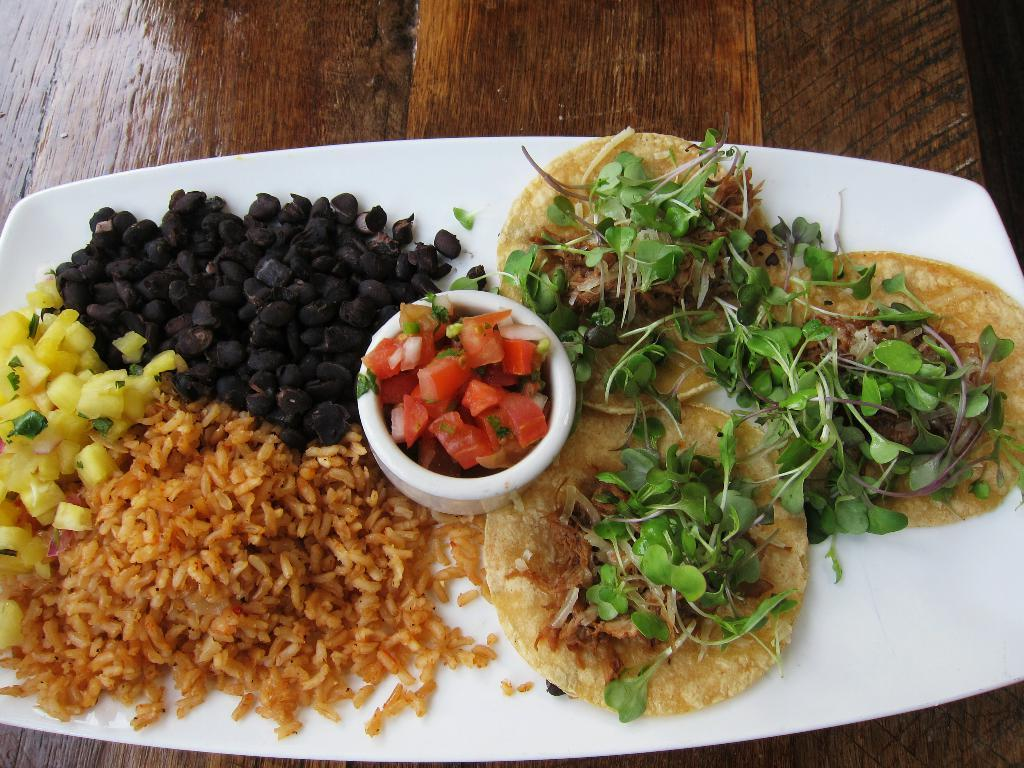What is on the plate in the image? There are food items on a plate in the image. What else is on the plate besides the food items? There is a bowl with food placed on the plate. On what surface is the plate placed? The plate is placed on a wooden surface. How many pizzas can be seen floating in the lake in the image? There are no pizzas or lakes present in the image; it features a plate with food items and a bowl on a wooden surface. 